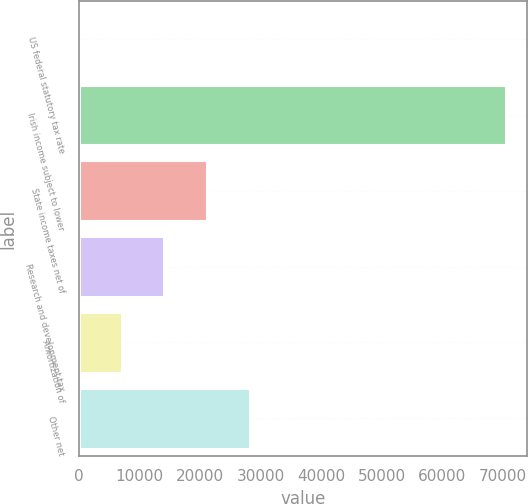Convert chart to OTSL. <chart><loc_0><loc_0><loc_500><loc_500><bar_chart><fcel>US federal statutory tax rate<fcel>Irish income subject to lower<fcel>State income taxes net of<fcel>Research and development tax<fcel>Amortization of<fcel>Other net<nl><fcel>35<fcel>70515<fcel>21179<fcel>14131<fcel>7083<fcel>28227<nl></chart> 